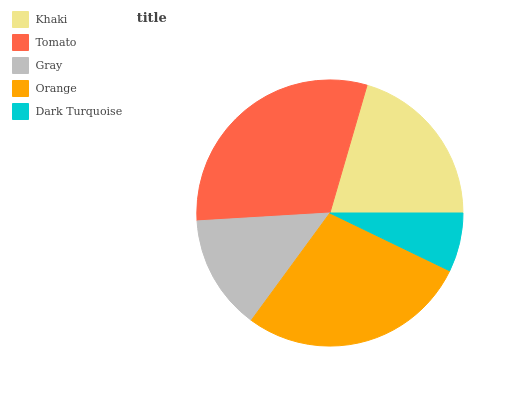Is Dark Turquoise the minimum?
Answer yes or no. Yes. Is Tomato the maximum?
Answer yes or no. Yes. Is Gray the minimum?
Answer yes or no. No. Is Gray the maximum?
Answer yes or no. No. Is Tomato greater than Gray?
Answer yes or no. Yes. Is Gray less than Tomato?
Answer yes or no. Yes. Is Gray greater than Tomato?
Answer yes or no. No. Is Tomato less than Gray?
Answer yes or no. No. Is Khaki the high median?
Answer yes or no. Yes. Is Khaki the low median?
Answer yes or no. Yes. Is Dark Turquoise the high median?
Answer yes or no. No. Is Dark Turquoise the low median?
Answer yes or no. No. 